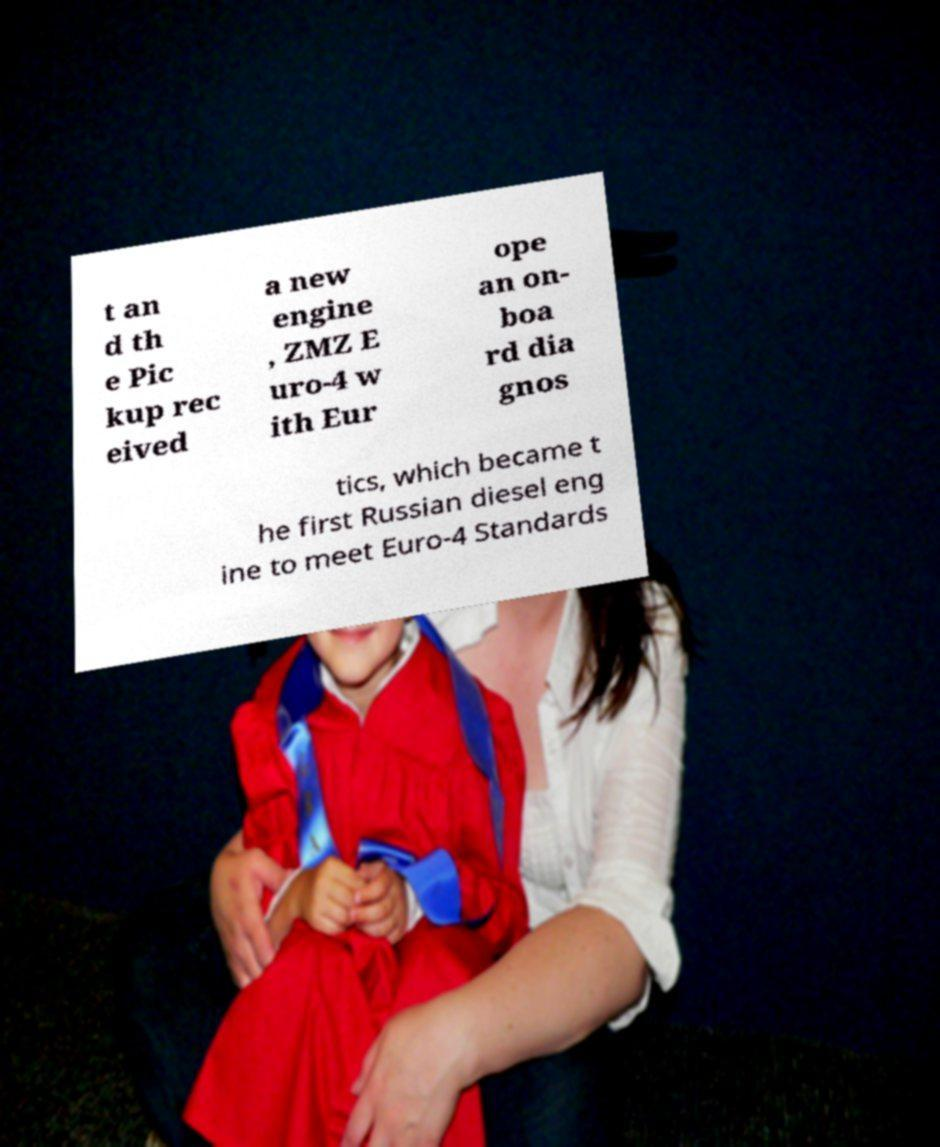Can you accurately transcribe the text from the provided image for me? t an d th e Pic kup rec eived a new engine , ZMZ E uro-4 w ith Eur ope an on- boa rd dia gnos tics, which became t he first Russian diesel eng ine to meet Euro-4 Standards 